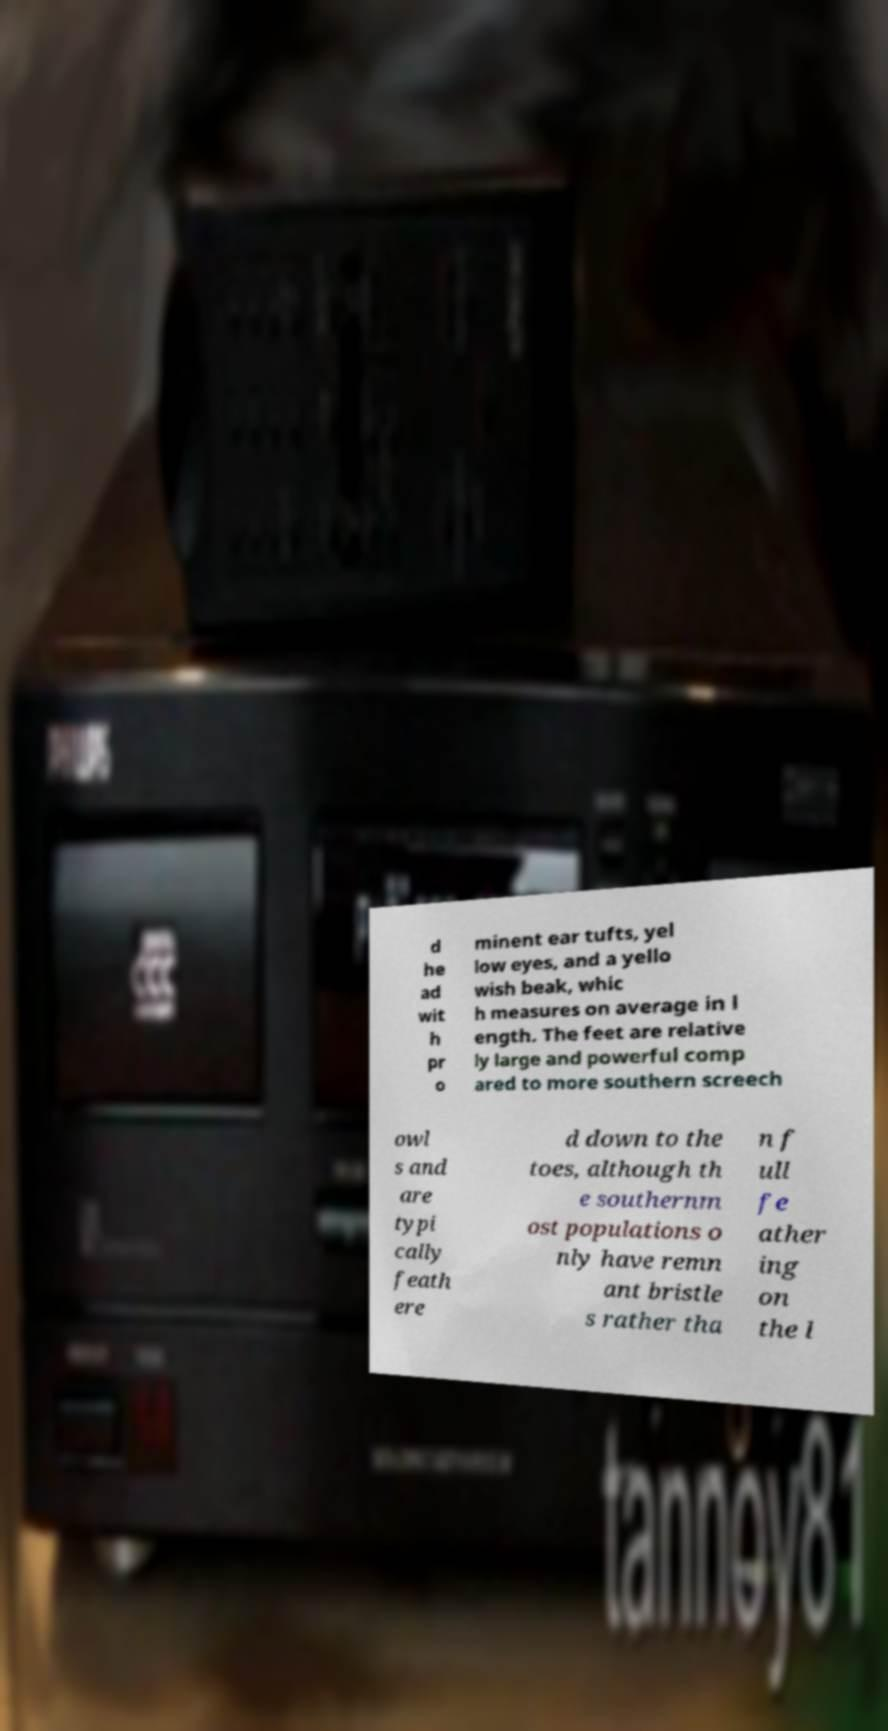Please read and relay the text visible in this image. What does it say? d he ad wit h pr o minent ear tufts, yel low eyes, and a yello wish beak, whic h measures on average in l ength. The feet are relative ly large and powerful comp ared to more southern screech owl s and are typi cally feath ere d down to the toes, although th e southernm ost populations o nly have remn ant bristle s rather tha n f ull fe ather ing on the l 